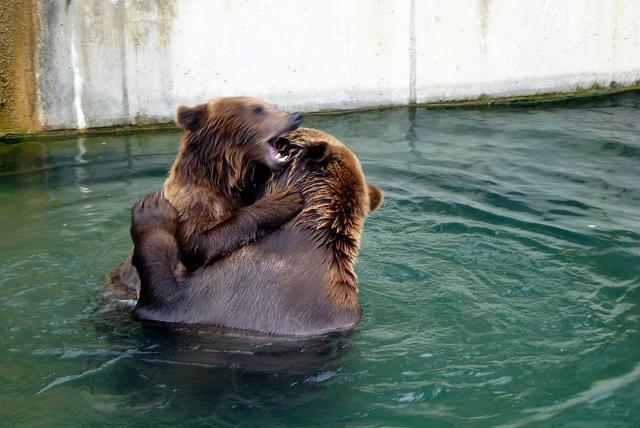How many bears are visible?
Give a very brief answer. 2. How many men are wearing white in the image?
Give a very brief answer. 0. 